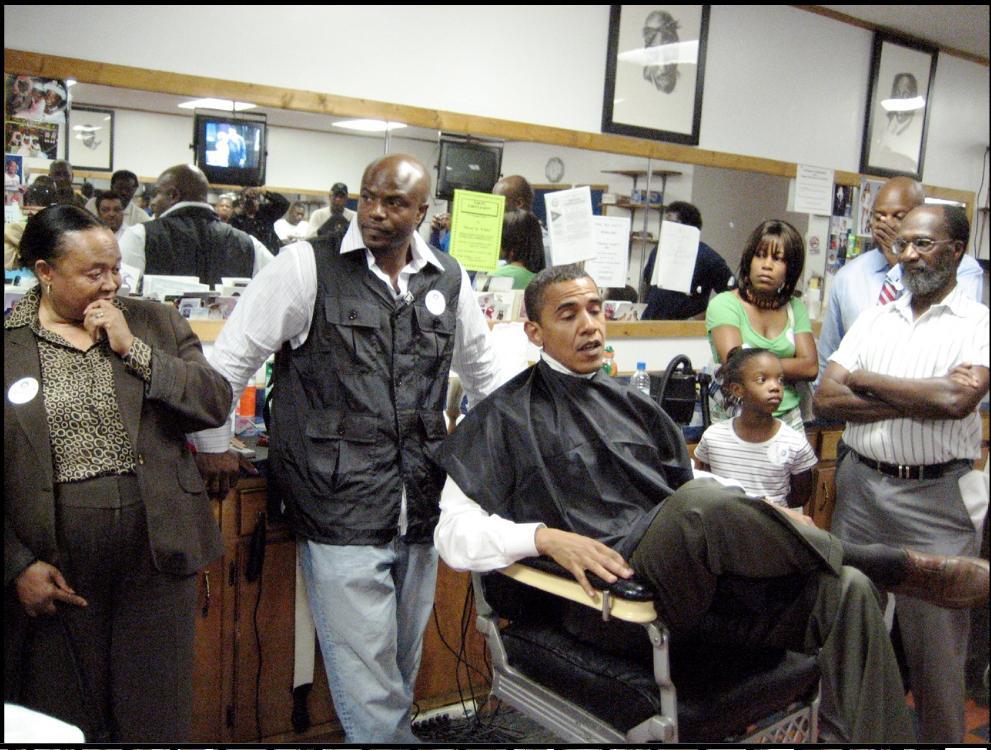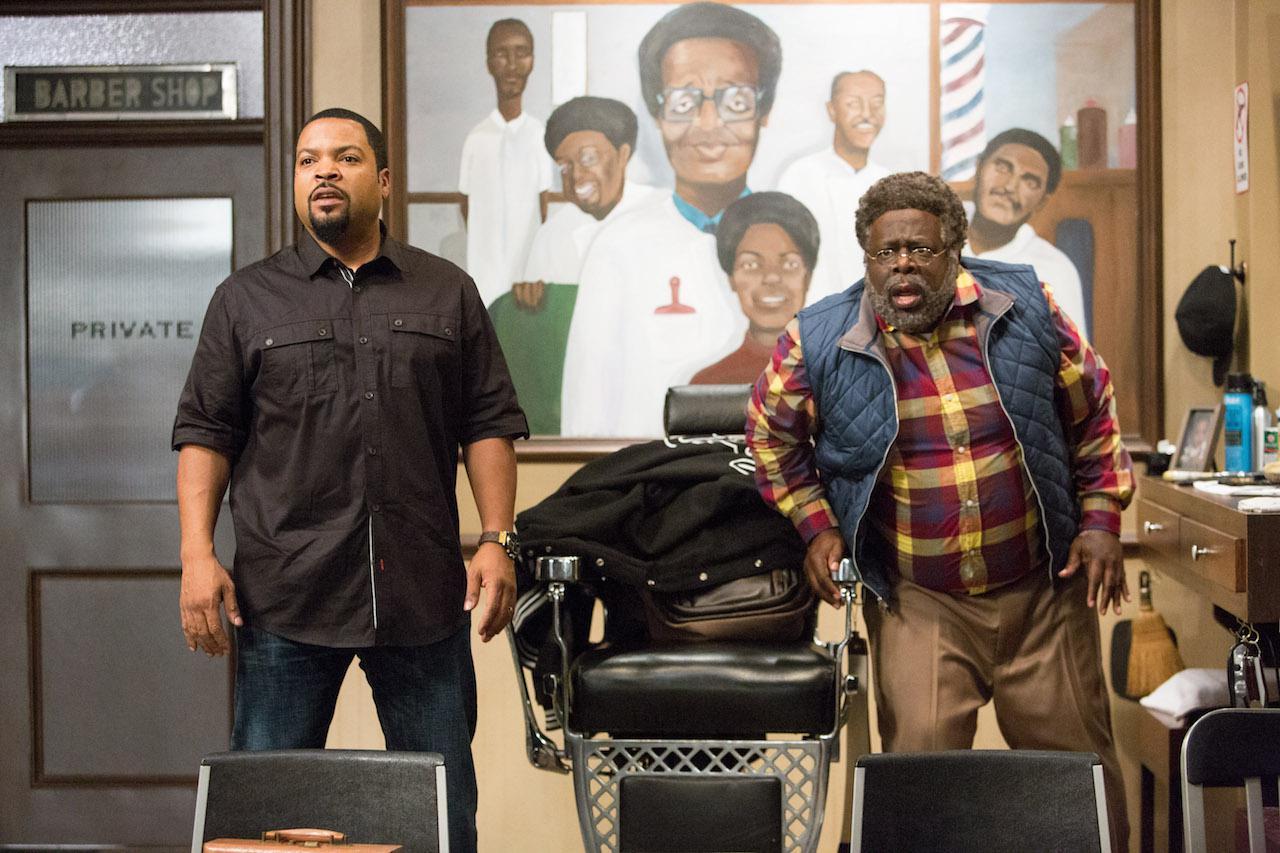The first image is the image on the left, the second image is the image on the right. Given the left and right images, does the statement "There is at least five people in a barber shop." hold true? Answer yes or no. Yes. The first image is the image on the left, the second image is the image on the right. Examine the images to the left and right. Is the description "All the people are African Americans." accurate? Answer yes or no. Yes. 